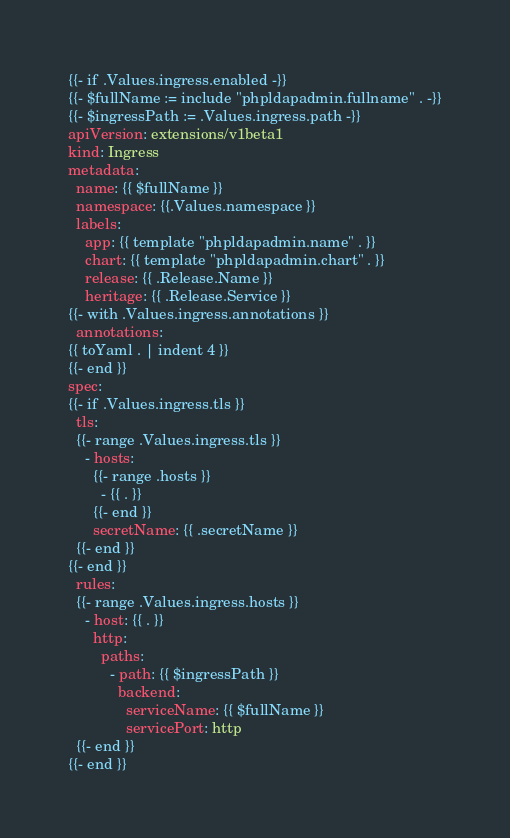Convert code to text. <code><loc_0><loc_0><loc_500><loc_500><_YAML_>{{- if .Values.ingress.enabled -}}
{{- $fullName := include "phpldapadmin.fullname" . -}}
{{- $ingressPath := .Values.ingress.path -}}
apiVersion: extensions/v1beta1
kind: Ingress
metadata:
  name: {{ $fullName }}
  namespace: {{.Values.namespace }}
  labels:
    app: {{ template "phpldapadmin.name" . }}
    chart: {{ template "phpldapadmin.chart" . }}
    release: {{ .Release.Name }}
    heritage: {{ .Release.Service }}
{{- with .Values.ingress.annotations }}
  annotations:
{{ toYaml . | indent 4 }}
{{- end }}
spec:
{{- if .Values.ingress.tls }}
  tls:
  {{- range .Values.ingress.tls }}
    - hosts:
      {{- range .hosts }}
        - {{ . }}
      {{- end }}
      secretName: {{ .secretName }}
  {{- end }}
{{- end }}
  rules:
  {{- range .Values.ingress.hosts }}
    - host: {{ . }}
      http:
        paths:
          - path: {{ $ingressPath }}
            backend:
              serviceName: {{ $fullName }}
              servicePort: http
  {{- end }}
{{- end }}
</code> 